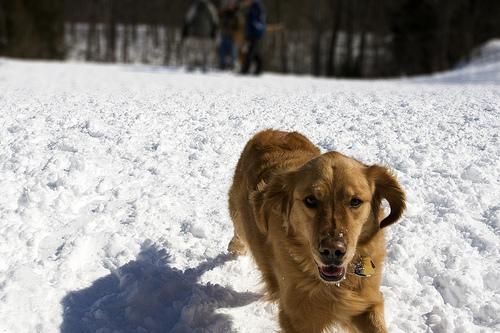What are the objects in the top-left corner of the image? In the top-left corner, there is a large group of trees, white trampled snow, and some parts of people. How would you describe the emotion the dog is currently depicting in the image? The dog appears to be playful and happy, as it has its mouth open and is looking at the camera with an expressive face. Count the number of eyes, ears, and tags visible on the dog. There are 2 eyes, 2 ears, and 1 tag visible on the dog. What kind of shadow is visible on the snow, and what object created it? The shadow of the dog is visible on the snow, created by the dog itself. Describe the weather condition and the effect on the environment in this image. The weather is snowy, leaving the ground covered in fluffy, white snow, with the sun shining on it, causing shadows of the dog and trees. Provide a detailed description of the dog's facial features. The dog has brown eyes, a light brown nose, curvy floppy ears, a pink tongue, and a small open mouth. Tell me about the people in the background of the image. There is a group of people standing behind the dog, one person is wearing a blue and black jacket, and others have black pants or blue pants on. Explain the interaction between the dog and its surroundings. The dog is standing in the snow, casting a shadow on the ground, while looking at the camera and being surrounded by a group of people, some of whom are wearing colorful clothing. What is the primary object in this image and what is it doing? A dog in the snow is the primary object, and it is looking at the camera with its mouth open and ears curvy. Is there any text on the dog's collar and if so, what does it say? Yes, there is a silver name tag on the dog's collar, but the text is not visible in the image. 